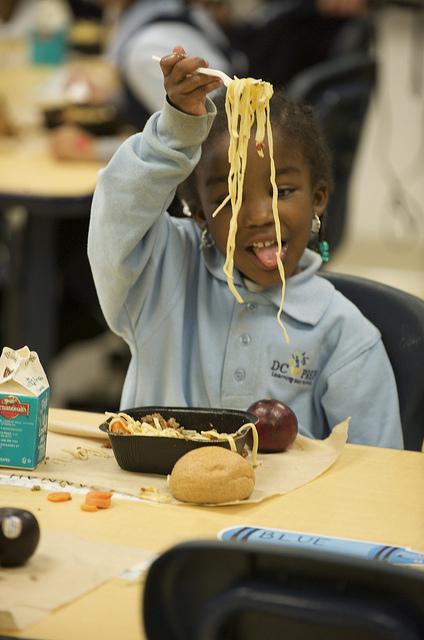What is the fruit on the table?
Write a very short answer. Apple. What is this girl eating?
Concise answer only. Spaghetti. What is the girl trying to do?
Write a very short answer. Eat spaghetti. 